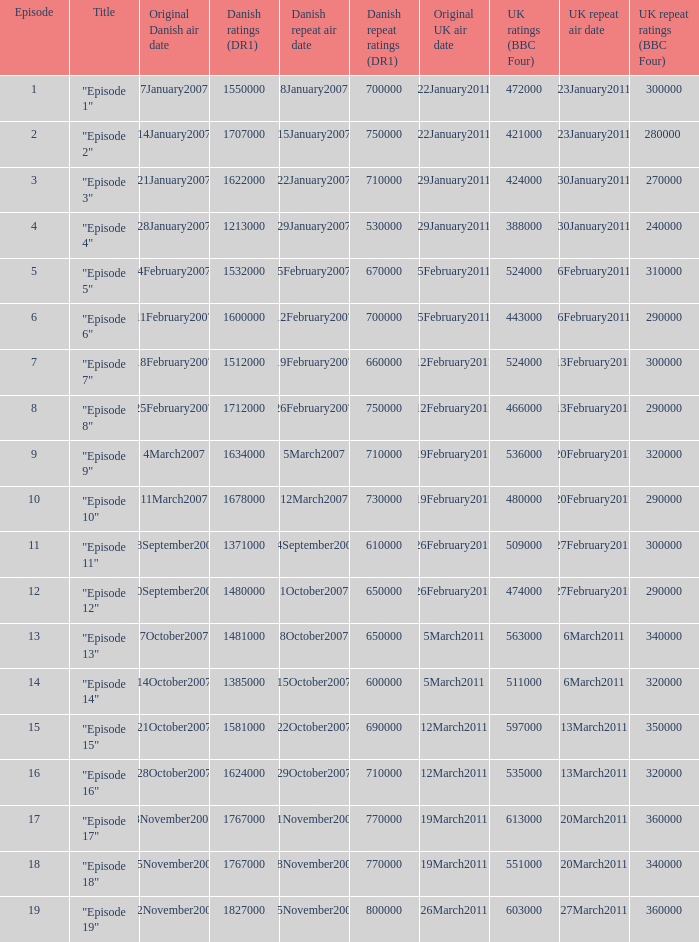What is the original Danish air date of "Episode 17"?  8November2007. 